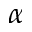Convert formula to latex. <formula><loc_0><loc_0><loc_500><loc_500>\alpha</formula> 